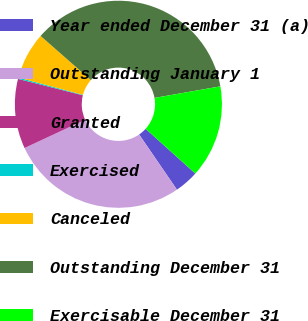<chart> <loc_0><loc_0><loc_500><loc_500><pie_chart><fcel>Year ended December 31 (a)<fcel>Outstanding January 1<fcel>Granted<fcel>Exercised<fcel>Canceled<fcel>Outstanding December 31<fcel>Exercisable December 31<nl><fcel>3.77%<fcel>27.62%<fcel>10.88%<fcel>0.21%<fcel>7.32%<fcel>35.76%<fcel>14.43%<nl></chart> 